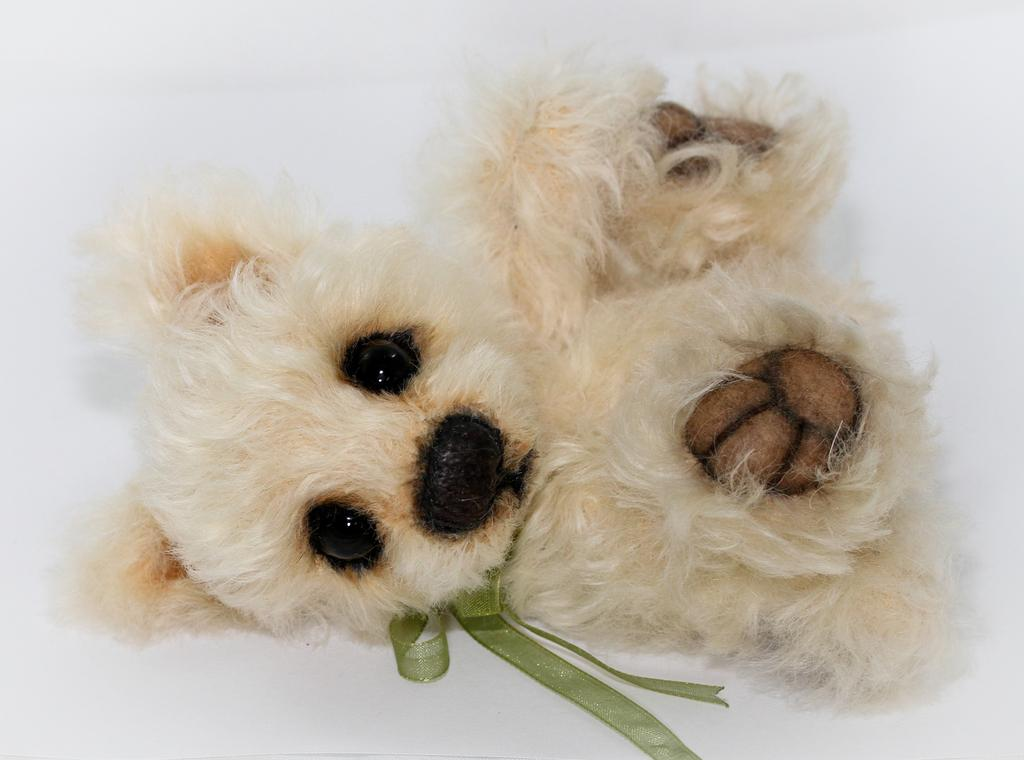What type of object is in the image? There is a soft toy in the image. Can you describe any specific details about the soft toy? The soft toy has a green ribbon around its neck. What color is the background of the image? The background of the image is white. How many snakes are coiled around the soft toy in the image? There are no snakes present in the image; it only features a soft toy with a green ribbon around its neck. 